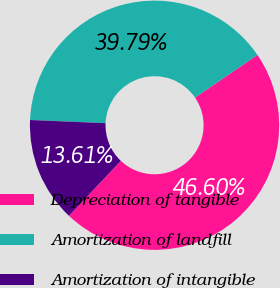<chart> <loc_0><loc_0><loc_500><loc_500><pie_chart><fcel>Depreciation of tangible<fcel>Amortization of landfill<fcel>Amortization of intangible<nl><fcel>46.6%<fcel>39.79%<fcel>13.61%<nl></chart> 